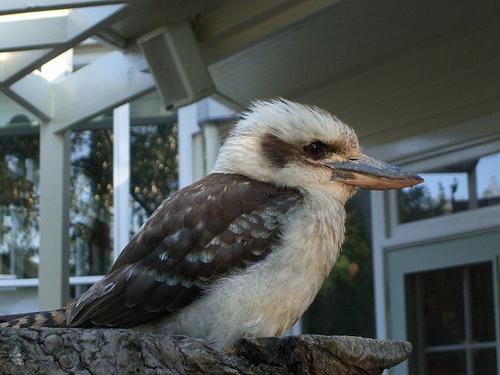Bird or cow?
Write a very short answer. Bird. Is the bird indoors or outdoors?
Be succinct. Outdoors. Is the bird awake?
Concise answer only. Yes. 